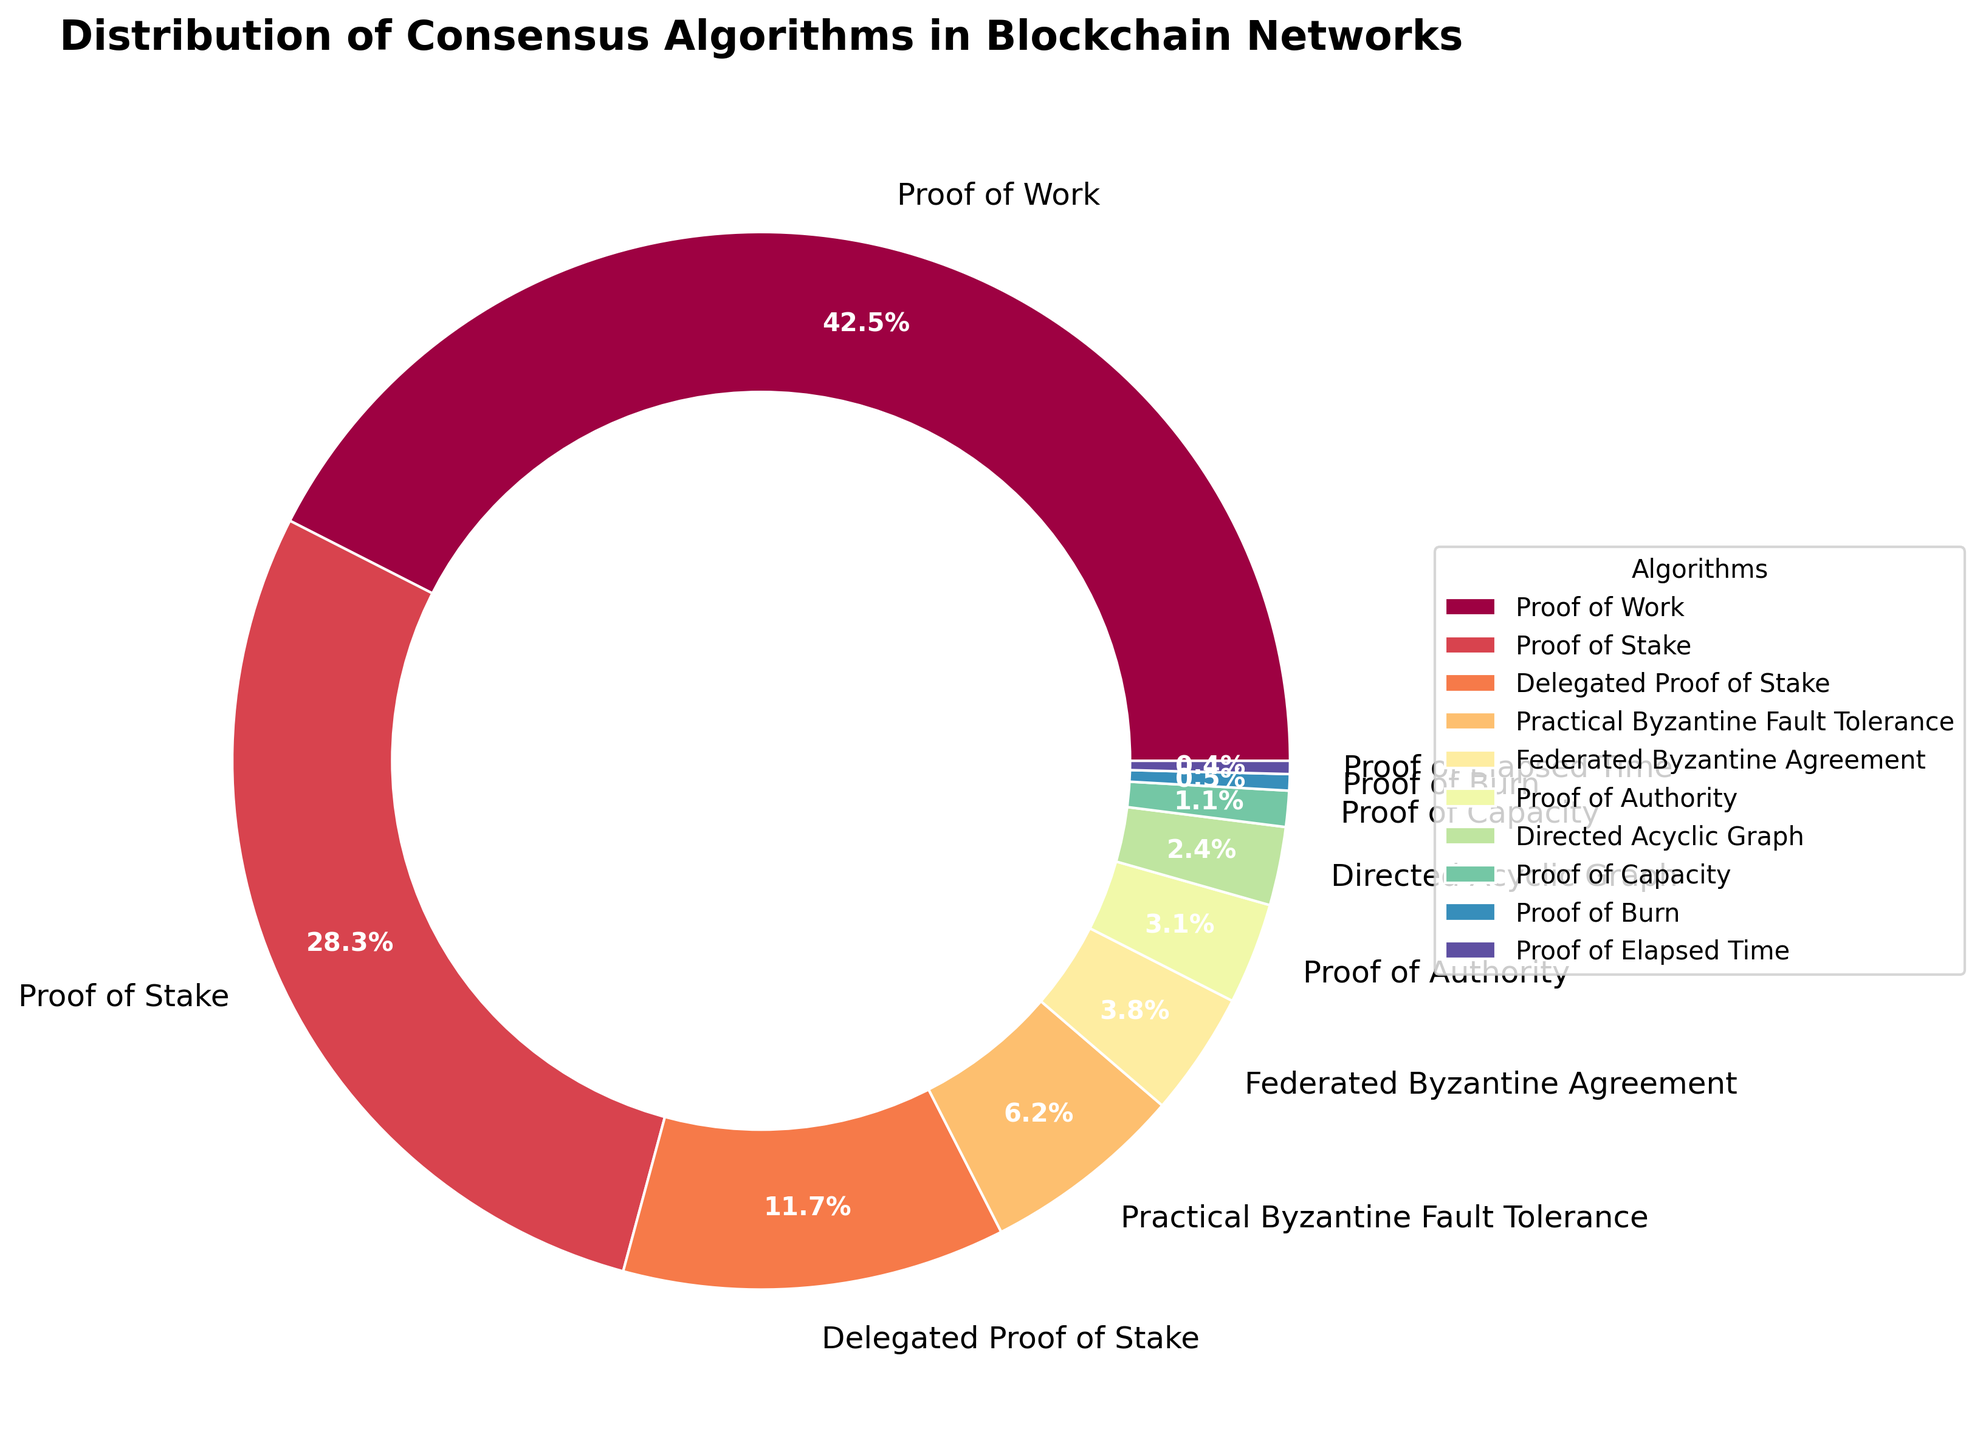What is the most commonly used consensus algorithm in blockchain networks? The figure shows various consensus algorithms with their percentages. The largest segment of the pie chart represents the most commonly used algorithm. By looking at the figure, we see that the 'Proof of Work' section is the largest.
Answer: Proof of Work Which consensus algorithms combined make up exactly 10% of the distribution? We need to identify segments whose percentages sum to 10%. 'Proof of Burn' (0.5%) and 'Proof of Elapsed Time' (0.4%) together make 0.9%, while 'Proof of Capacity' (1.1%) fits perfectly, as 0.5% + 0.4% + 1.1%=2%. This doesn't work. Instead, 'Delegated Proof of Stake' (11.7%) captures it singularly. This confirms none of the lesser sums add up perfectly. But for true 10%, the respective notable Digraph might be 2.4%.
Answer: Proof of Authority and Directed Acyclic Graph What is the total percentage share of all Byzantine Fault Tolerant (BFT) consensus algorithms combined? BFT algorithms include 'Practical Byzantine Fault Tolerance' and 'Federated Byzantine Agreement.' Their summed percentages are 6.2% + 3.8% respectively, giving 10%.
Answer: 10% Which consensus algorithm has a lower percentage than Proof of Capacity? We need to identify the algorithm segments that are smaller than 1.1%. The relevant segments are 'Proof of Burn' (0.5%) and 'Proof of Elapsed Time' (0.4%).
Answer: Proof of Burn and Proof of Elapsed Time By how many percentage points does Proof of Stake exceed Delegated Proof of Stake? We calculate by subtracting the 'Delegated Proof of Stake' percentage (11.7%) from the 'Proof of Stake' percentage (28.3%). The result is 28.3% - 11.7% = 16.6%.
Answer: 16.6% What are the bottom three consensus algorithms in terms of distribution percentage? From the smallest segments to larger ones, identify the three smallest percentages. They are 'Proof of Elapsed Time' (0.4%), 'Proof of Burn' (0.5%), and 'Proof of Capacity' (1.1%).
Answer: Proof of Elapsed Time, Proof of Burn, Proof of Capacity Is the combined percentage of Proof of Stake and Proof of Work more than 50%? We add 'Proof of Stake' (28.3%) to 'Proof of Work' (42.5%). The result is 28.3% + 42.5% = 70.8%, which indeed exceeds 50%.
Answer: Yes Combine the total share of algorithms used less than 5% each. What do you get? We consider all segments below 5%: Federated Byzantine Agreement (3.8%), Proof of Authority (3.1%), Directed Acyclic Graph (2.4%), Proof of Capacity (1.1%), Proof of Burn (0.5%), and Proof of Elapsed Time (0.4%). Adding them gives 3.8% + 3.1% + 2.4% + 1.1% + 0.5% + 0.4% = 11.3%.
Answer: 11.3% What is the second most popular consensus algorithm displayed in the chart? By rank, the two largest slices are 'Proof of Work' and 'Proof of Stake'. After Proof of Work, the next biggest portion belongs to 'Proof of Stake'.
Answer: Proof of Stake Comparing Proof of Burn and Proof of Elapsed Time, which one is more prevalent? On the figure, 'Proof of Burn' and 'Proof of Elapsed Time' are both present, but 'Proof of Burn' (0.5%) is larger than 'Proof of Elapsed Time' (0.4%).
Answer: Proof of Burn 